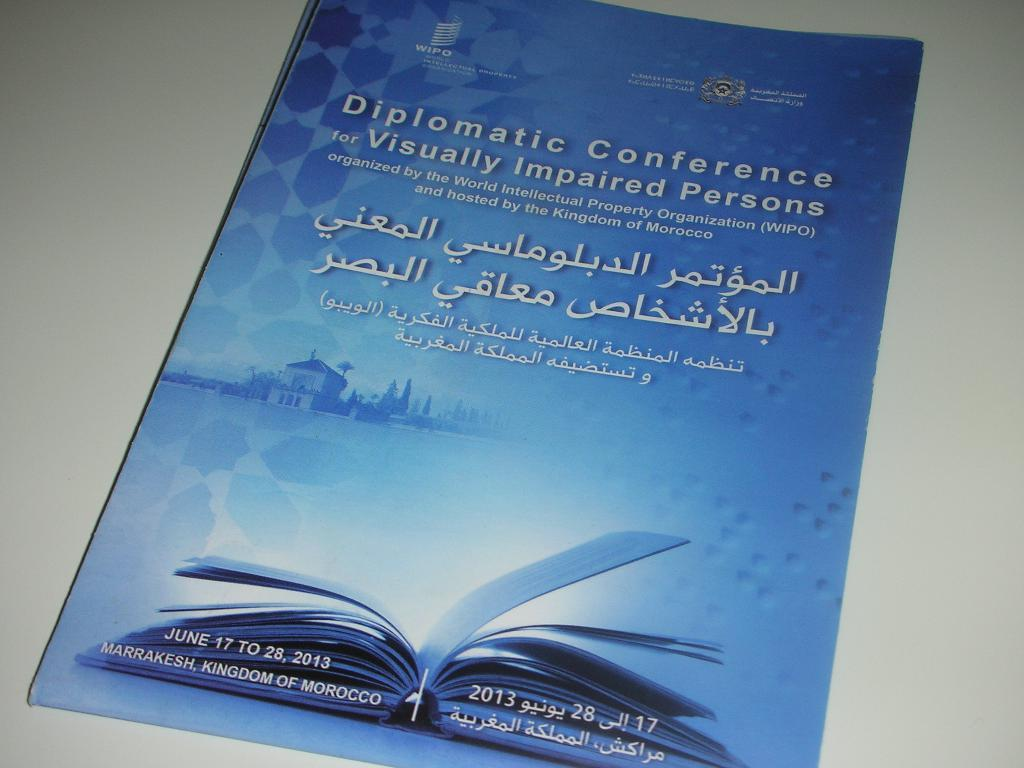<image>
Relay a brief, clear account of the picture shown. a flyer for a Diplomatic Conference for Visually Impaired Persons 